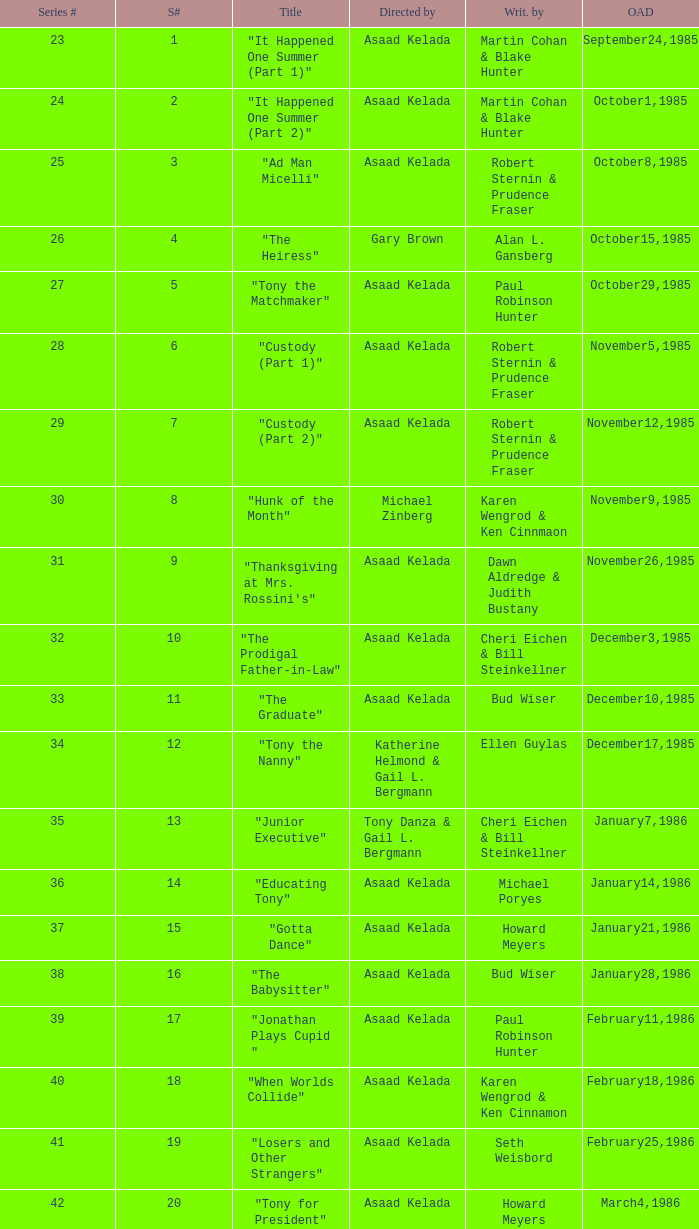What is the date of the episode written by Michael Poryes? January14,1986. 